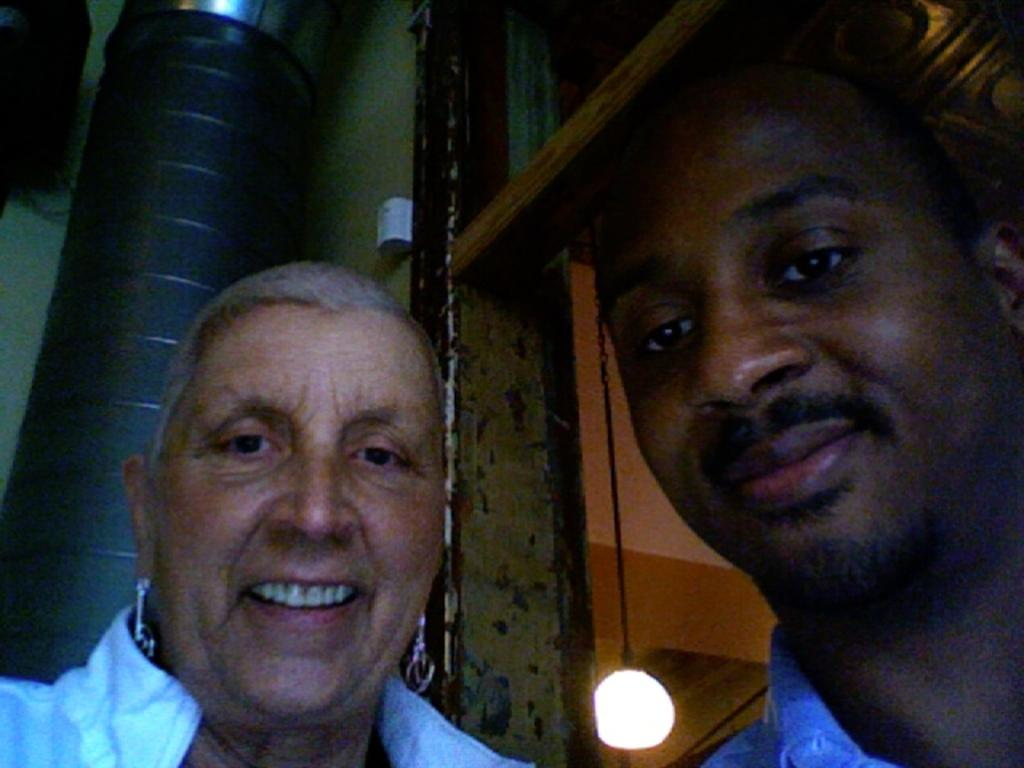How many men are in the foreground of the image? There are two men in the foreground of the image. What is the facial expression of the men? The men are smiling. What can be seen in the background of the image? There is a light, a chain, wooden sticks, and other unspecified objects in the background of the image. What type of waste can be seen in the image? There is no waste present in the image. Can you describe the print on the men's shirts in the image? There is no information about the men's shirts or any prints on them in the provided facts. --- Facts: 1. There is a car in the image. 2. The car is red. 3. The car has four wheels. 4. There is a road in the image. 5. The road is paved. 6. There are trees on the side of the road. Absurd Topics: parrot, ocean, dance Conversation: What is the color of the car in the image? The car is red. How many wheels does the car have? The car has four wheels. What can be seen in the background of the image? There is a road in the image, and the road is paved. What type of vegetation is on the side of the road? There are trees on the side of the road. Reasoning: Let's think step by step in order to produce the conversation. We start by identifying the main subject in the image, which is the red car. Then, we describe the car's features, such as the number of wheels. Next, we expand the conversation to include the various objects visible in the background of the image, including the road and trees. Each question is designed to elicit a specific detail about the image that is known from the provided facts. Absurd Question/Answer: Can you tell me how many parrots are sitting on the car in the image? There are no parrots present in the image. Is the car parked near the ocean in the image? There is no information about the ocean or any body of water in the provided facts. 